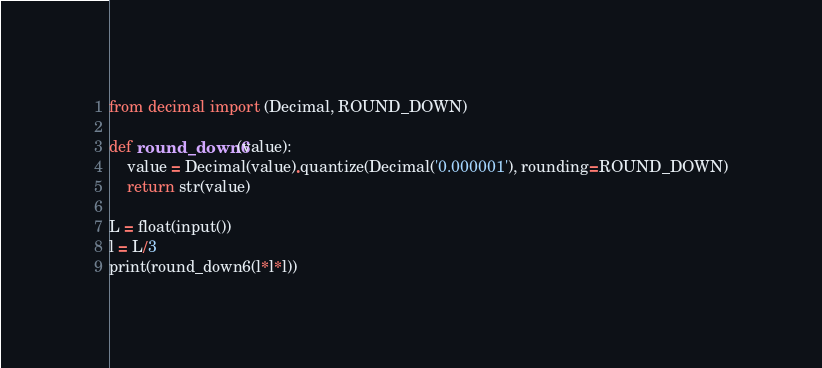<code> <loc_0><loc_0><loc_500><loc_500><_Python_>from decimal import (Decimal, ROUND_DOWN)

def round_down6(value):
    value = Decimal(value).quantize(Decimal('0.000001'), rounding=ROUND_DOWN)
    return str(value)

L = float(input())
l = L/3
print(round_down6(l*l*l))</code> 